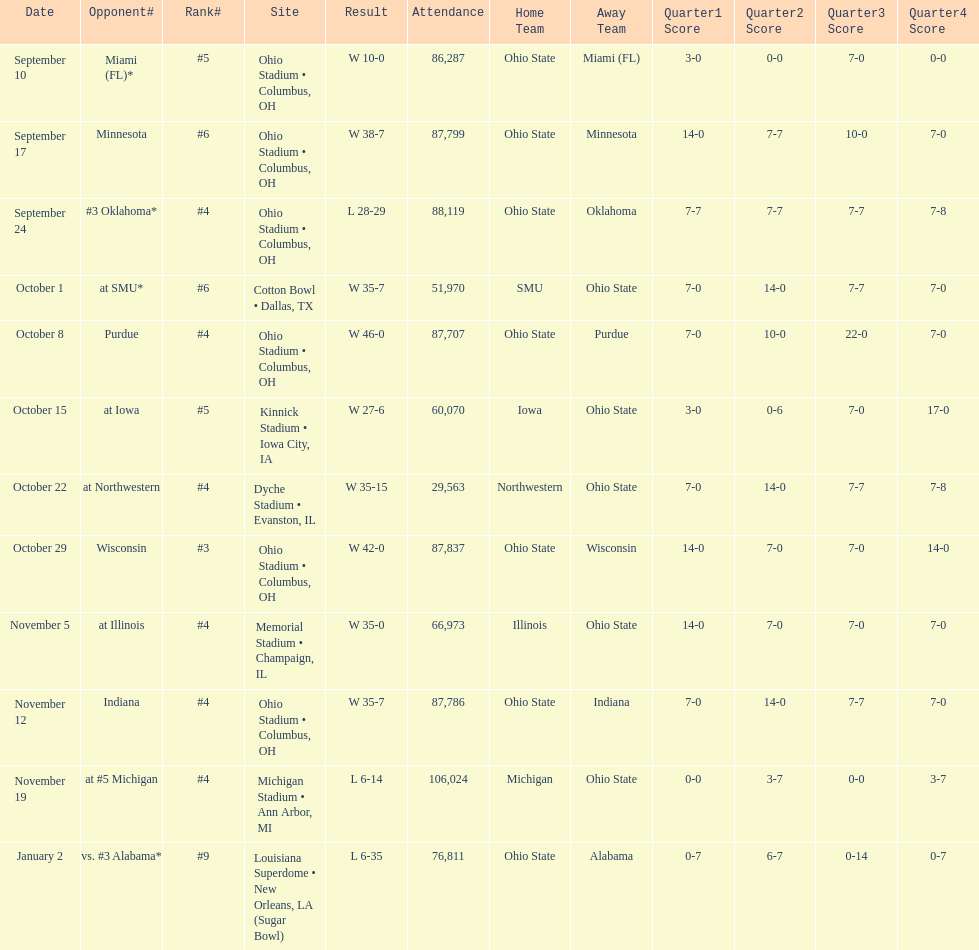What is the difference between the number of wins and the number of losses? 6. 